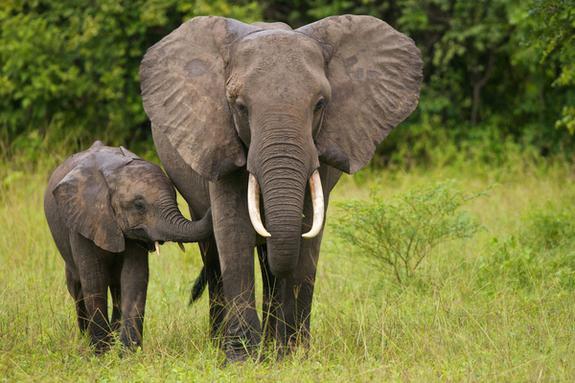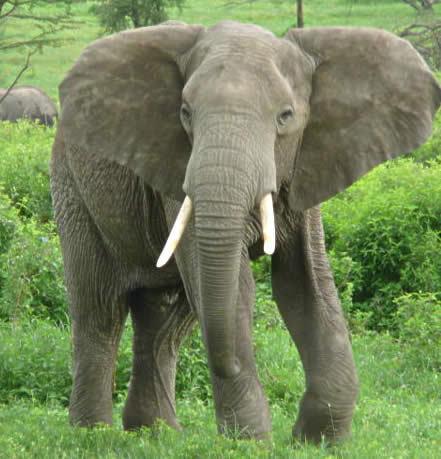The first image is the image on the left, the second image is the image on the right. Given the left and right images, does the statement "An image shows just one elephant in the foreground." hold true? Answer yes or no. Yes. 